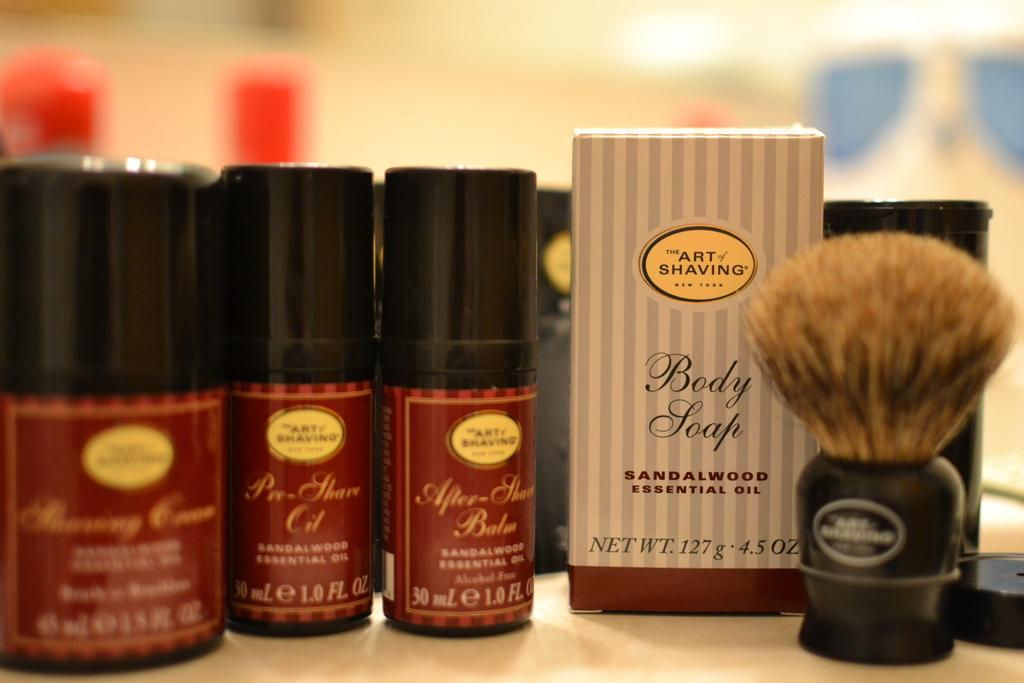<image>
Render a clear and concise summary of the photo. A shaving brush next to some shaving soap. 